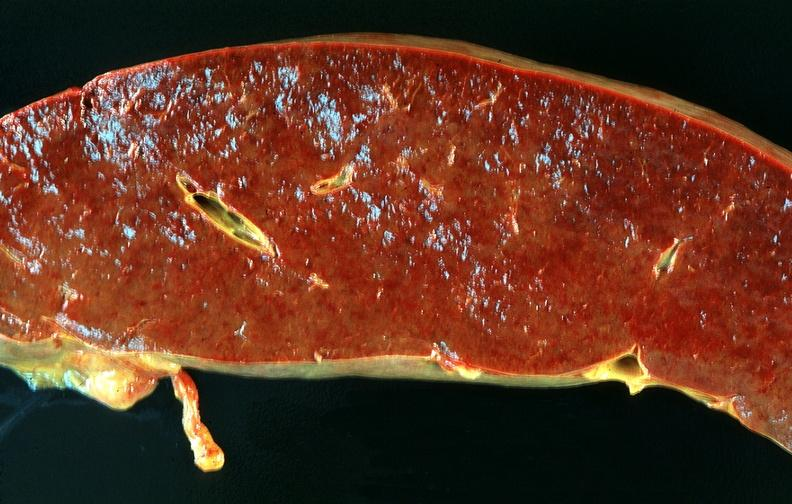does gout show spleen, chronic congestion due to portal hypertension from cirrhosis, hcv?
Answer the question using a single word or phrase. No 